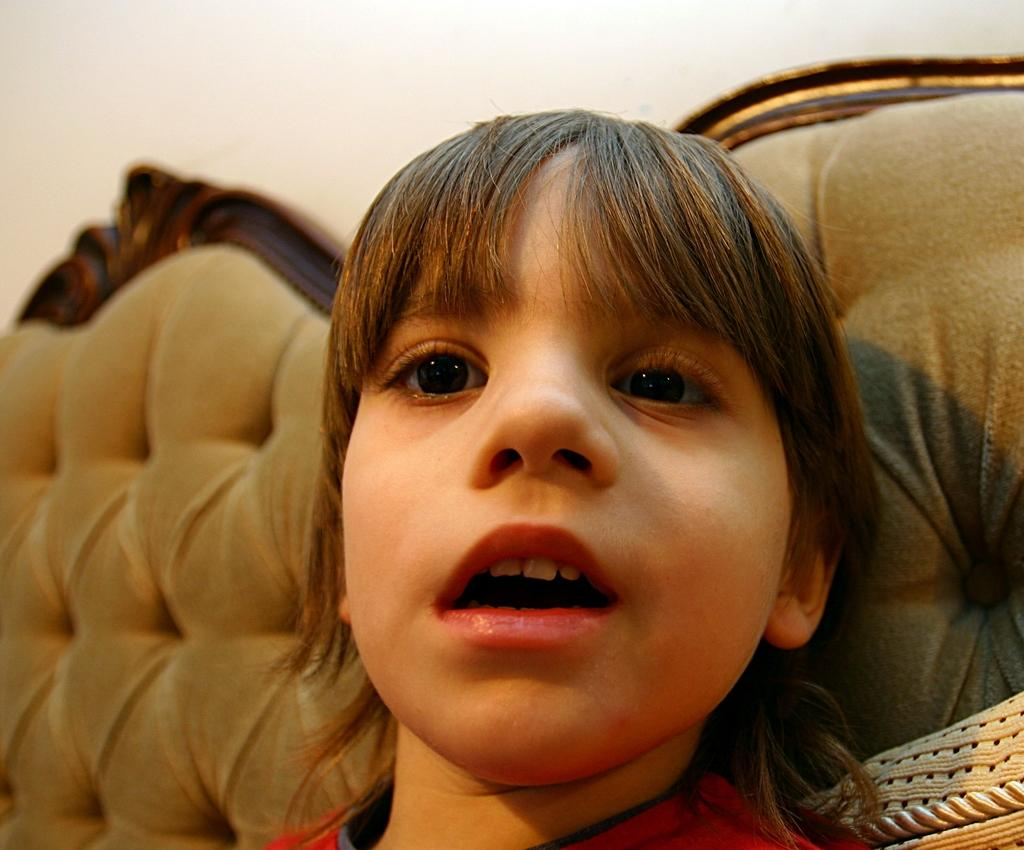Who is the main subject in the image? There is a girl in the image. What is the girl doing in the image? The girl is sitting on a sofa and opening her mouth. What can be seen in the background of the image? There is a wall in the background of the image. What type of quince is the girl holding in the image? There is no quince present in the image. How does the girl plan to increase her vocabulary while sitting on the sofa? The image does not provide information about the girl's intentions or actions related to increasing her vocabulary. 